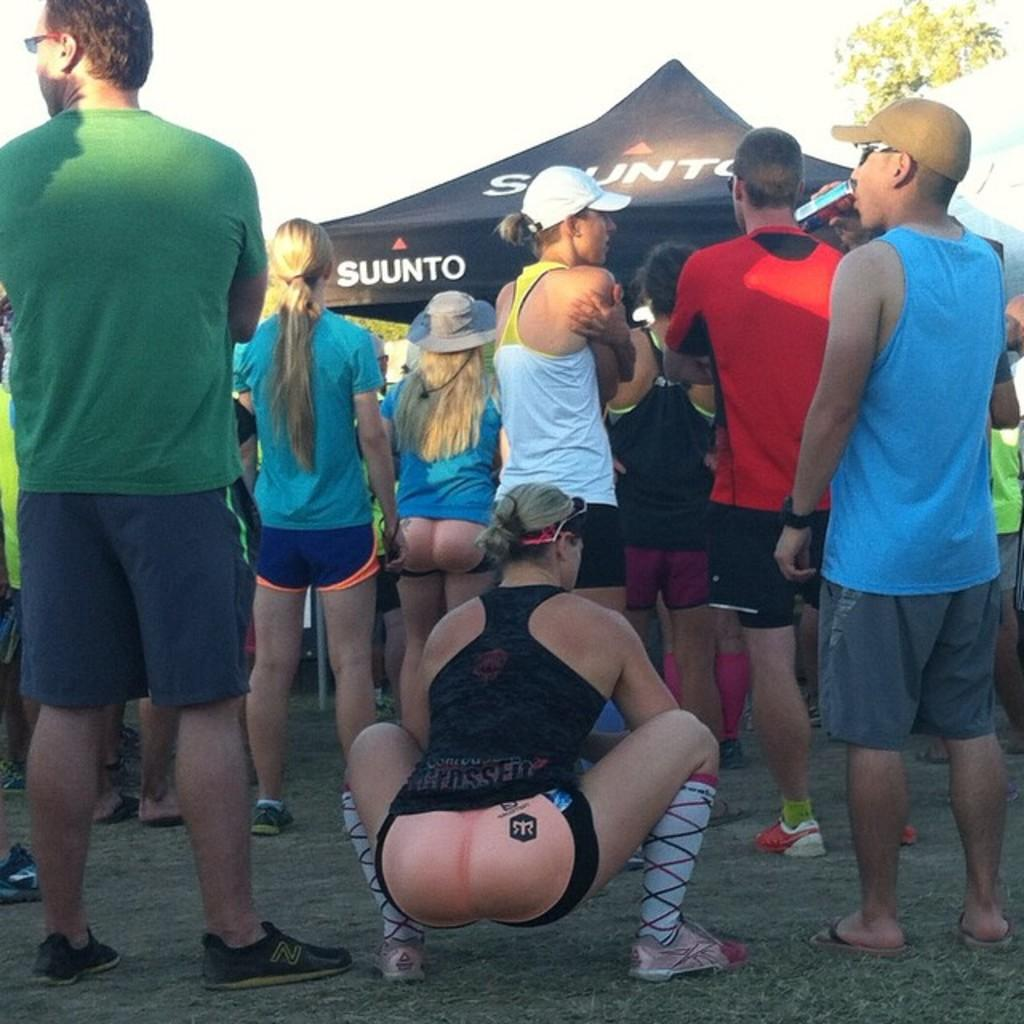<image>
Provide a brief description of the given image. A tent with the word SUUNTO can be seen behind a crowd of people. 